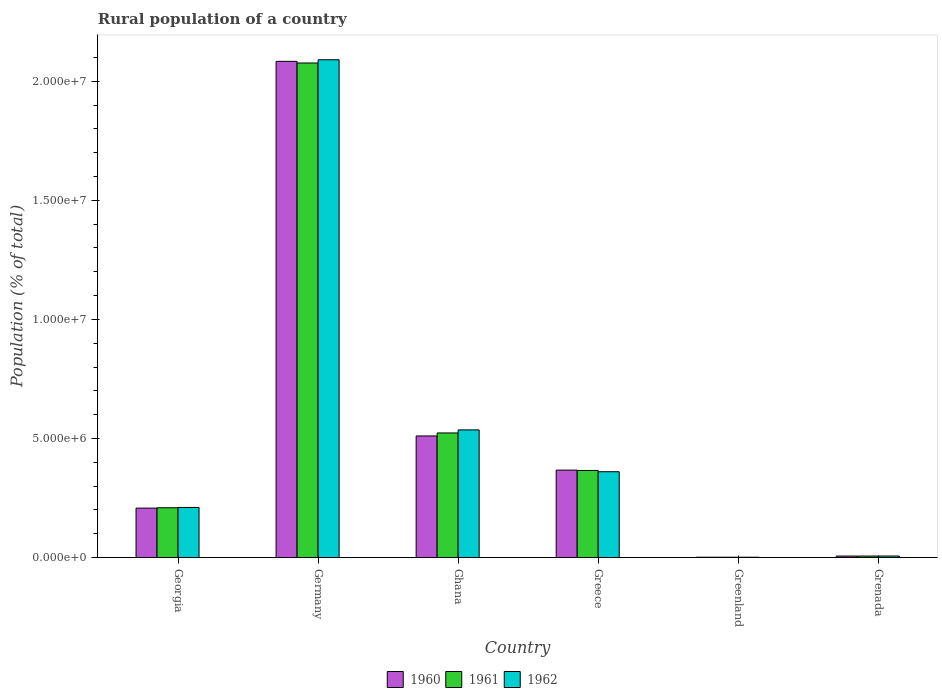How many groups of bars are there?
Provide a short and direct response. 6. What is the label of the 4th group of bars from the left?
Give a very brief answer. Greece. What is the rural population in 1960 in Greenland?
Provide a succinct answer. 1.35e+04. Across all countries, what is the maximum rural population in 1960?
Your answer should be compact. 2.08e+07. Across all countries, what is the minimum rural population in 1960?
Offer a very short reply. 1.35e+04. In which country was the rural population in 1961 maximum?
Provide a succinct answer. Germany. In which country was the rural population in 1962 minimum?
Your answer should be very brief. Greenland. What is the total rural population in 1961 in the graph?
Give a very brief answer. 3.18e+07. What is the difference between the rural population in 1960 in Greece and that in Grenada?
Make the answer very short. 3.61e+06. What is the difference between the rural population in 1960 in Ghana and the rural population in 1962 in Grenada?
Your response must be concise. 5.04e+06. What is the average rural population in 1962 per country?
Your answer should be very brief. 5.34e+06. What is the difference between the rural population of/in 1960 and rural population of/in 1961 in Ghana?
Your answer should be very brief. -1.27e+05. What is the ratio of the rural population in 1962 in Greenland to that in Grenada?
Your answer should be compact. 0.21. What is the difference between the highest and the second highest rural population in 1961?
Provide a succinct answer. 1.58e+06. What is the difference between the highest and the lowest rural population in 1961?
Ensure brevity in your answer.  2.08e+07. In how many countries, is the rural population in 1962 greater than the average rural population in 1962 taken over all countries?
Ensure brevity in your answer.  2. Is the sum of the rural population in 1962 in Georgia and Grenada greater than the maximum rural population in 1960 across all countries?
Provide a short and direct response. No. How many bars are there?
Ensure brevity in your answer.  18. What is the difference between two consecutive major ticks on the Y-axis?
Provide a succinct answer. 5.00e+06. Does the graph contain grids?
Your response must be concise. No. What is the title of the graph?
Your response must be concise. Rural population of a country. Does "1968" appear as one of the legend labels in the graph?
Keep it short and to the point. No. What is the label or title of the Y-axis?
Offer a very short reply. Population (% of total). What is the Population (% of total) in 1960 in Georgia?
Your response must be concise. 2.08e+06. What is the Population (% of total) of 1961 in Georgia?
Offer a very short reply. 2.09e+06. What is the Population (% of total) in 1962 in Georgia?
Your response must be concise. 2.10e+06. What is the Population (% of total) of 1960 in Germany?
Provide a succinct answer. 2.08e+07. What is the Population (% of total) in 1961 in Germany?
Make the answer very short. 2.08e+07. What is the Population (% of total) of 1962 in Germany?
Provide a succinct answer. 2.09e+07. What is the Population (% of total) in 1960 in Ghana?
Give a very brief answer. 5.11e+06. What is the Population (% of total) in 1961 in Ghana?
Provide a succinct answer. 5.23e+06. What is the Population (% of total) in 1962 in Ghana?
Keep it short and to the point. 5.36e+06. What is the Population (% of total) in 1960 in Greece?
Provide a short and direct response. 3.67e+06. What is the Population (% of total) in 1961 in Greece?
Provide a succinct answer. 3.66e+06. What is the Population (% of total) of 1962 in Greece?
Make the answer very short. 3.60e+06. What is the Population (% of total) in 1960 in Greenland?
Make the answer very short. 1.35e+04. What is the Population (% of total) of 1961 in Greenland?
Provide a succinct answer. 1.35e+04. What is the Population (% of total) in 1962 in Greenland?
Offer a very short reply. 1.35e+04. What is the Population (% of total) of 1960 in Grenada?
Provide a short and direct response. 6.26e+04. What is the Population (% of total) in 1961 in Grenada?
Your answer should be compact. 6.34e+04. What is the Population (% of total) of 1962 in Grenada?
Give a very brief answer. 6.40e+04. Across all countries, what is the maximum Population (% of total) in 1960?
Provide a succinct answer. 2.08e+07. Across all countries, what is the maximum Population (% of total) of 1961?
Your response must be concise. 2.08e+07. Across all countries, what is the maximum Population (% of total) of 1962?
Your answer should be very brief. 2.09e+07. Across all countries, what is the minimum Population (% of total) in 1960?
Your answer should be very brief. 1.35e+04. Across all countries, what is the minimum Population (% of total) in 1961?
Your response must be concise. 1.35e+04. Across all countries, what is the minimum Population (% of total) of 1962?
Offer a terse response. 1.35e+04. What is the total Population (% of total) of 1960 in the graph?
Your answer should be compact. 3.18e+07. What is the total Population (% of total) of 1961 in the graph?
Provide a succinct answer. 3.18e+07. What is the total Population (% of total) in 1962 in the graph?
Offer a very short reply. 3.20e+07. What is the difference between the Population (% of total) in 1960 in Georgia and that in Germany?
Your answer should be very brief. -1.88e+07. What is the difference between the Population (% of total) in 1961 in Georgia and that in Germany?
Provide a succinct answer. -1.87e+07. What is the difference between the Population (% of total) of 1962 in Georgia and that in Germany?
Your response must be concise. -1.88e+07. What is the difference between the Population (% of total) in 1960 in Georgia and that in Ghana?
Offer a very short reply. -3.03e+06. What is the difference between the Population (% of total) in 1961 in Georgia and that in Ghana?
Make the answer very short. -3.14e+06. What is the difference between the Population (% of total) of 1962 in Georgia and that in Ghana?
Ensure brevity in your answer.  -3.26e+06. What is the difference between the Population (% of total) in 1960 in Georgia and that in Greece?
Offer a terse response. -1.60e+06. What is the difference between the Population (% of total) in 1961 in Georgia and that in Greece?
Make the answer very short. -1.57e+06. What is the difference between the Population (% of total) in 1962 in Georgia and that in Greece?
Provide a short and direct response. -1.50e+06. What is the difference between the Population (% of total) of 1960 in Georgia and that in Greenland?
Provide a short and direct response. 2.06e+06. What is the difference between the Population (% of total) in 1961 in Georgia and that in Greenland?
Ensure brevity in your answer.  2.08e+06. What is the difference between the Population (% of total) of 1962 in Georgia and that in Greenland?
Offer a terse response. 2.09e+06. What is the difference between the Population (% of total) in 1960 in Georgia and that in Grenada?
Offer a terse response. 2.01e+06. What is the difference between the Population (% of total) of 1961 in Georgia and that in Grenada?
Keep it short and to the point. 2.03e+06. What is the difference between the Population (% of total) in 1962 in Georgia and that in Grenada?
Give a very brief answer. 2.04e+06. What is the difference between the Population (% of total) of 1960 in Germany and that in Ghana?
Your answer should be very brief. 1.57e+07. What is the difference between the Population (% of total) of 1961 in Germany and that in Ghana?
Give a very brief answer. 1.55e+07. What is the difference between the Population (% of total) in 1962 in Germany and that in Ghana?
Your answer should be compact. 1.55e+07. What is the difference between the Population (% of total) of 1960 in Germany and that in Greece?
Keep it short and to the point. 1.72e+07. What is the difference between the Population (% of total) of 1961 in Germany and that in Greece?
Your answer should be compact. 1.71e+07. What is the difference between the Population (% of total) of 1962 in Germany and that in Greece?
Provide a short and direct response. 1.73e+07. What is the difference between the Population (% of total) in 1960 in Germany and that in Greenland?
Your answer should be very brief. 2.08e+07. What is the difference between the Population (% of total) in 1961 in Germany and that in Greenland?
Your response must be concise. 2.08e+07. What is the difference between the Population (% of total) in 1962 in Germany and that in Greenland?
Make the answer very short. 2.09e+07. What is the difference between the Population (% of total) of 1960 in Germany and that in Grenada?
Your response must be concise. 2.08e+07. What is the difference between the Population (% of total) of 1961 in Germany and that in Grenada?
Provide a succinct answer. 2.07e+07. What is the difference between the Population (% of total) in 1962 in Germany and that in Grenada?
Provide a succinct answer. 2.08e+07. What is the difference between the Population (% of total) in 1960 in Ghana and that in Greece?
Offer a terse response. 1.43e+06. What is the difference between the Population (% of total) of 1961 in Ghana and that in Greece?
Give a very brief answer. 1.58e+06. What is the difference between the Population (% of total) of 1962 in Ghana and that in Greece?
Your answer should be compact. 1.76e+06. What is the difference between the Population (% of total) in 1960 in Ghana and that in Greenland?
Your answer should be very brief. 5.09e+06. What is the difference between the Population (% of total) of 1961 in Ghana and that in Greenland?
Your answer should be compact. 5.22e+06. What is the difference between the Population (% of total) of 1962 in Ghana and that in Greenland?
Provide a short and direct response. 5.35e+06. What is the difference between the Population (% of total) in 1960 in Ghana and that in Grenada?
Give a very brief answer. 5.04e+06. What is the difference between the Population (% of total) of 1961 in Ghana and that in Grenada?
Your answer should be compact. 5.17e+06. What is the difference between the Population (% of total) in 1962 in Ghana and that in Grenada?
Provide a short and direct response. 5.30e+06. What is the difference between the Population (% of total) in 1960 in Greece and that in Greenland?
Offer a terse response. 3.66e+06. What is the difference between the Population (% of total) in 1961 in Greece and that in Greenland?
Provide a short and direct response. 3.64e+06. What is the difference between the Population (% of total) in 1962 in Greece and that in Greenland?
Give a very brief answer. 3.59e+06. What is the difference between the Population (% of total) in 1960 in Greece and that in Grenada?
Keep it short and to the point. 3.61e+06. What is the difference between the Population (% of total) of 1961 in Greece and that in Grenada?
Provide a succinct answer. 3.59e+06. What is the difference between the Population (% of total) of 1962 in Greece and that in Grenada?
Give a very brief answer. 3.54e+06. What is the difference between the Population (% of total) of 1960 in Greenland and that in Grenada?
Your response must be concise. -4.91e+04. What is the difference between the Population (% of total) in 1961 in Greenland and that in Grenada?
Provide a short and direct response. -4.99e+04. What is the difference between the Population (% of total) of 1962 in Greenland and that in Grenada?
Give a very brief answer. -5.05e+04. What is the difference between the Population (% of total) in 1960 in Georgia and the Population (% of total) in 1961 in Germany?
Provide a short and direct response. -1.87e+07. What is the difference between the Population (% of total) in 1960 in Georgia and the Population (% of total) in 1962 in Germany?
Make the answer very short. -1.88e+07. What is the difference between the Population (% of total) of 1961 in Georgia and the Population (% of total) of 1962 in Germany?
Keep it short and to the point. -1.88e+07. What is the difference between the Population (% of total) in 1960 in Georgia and the Population (% of total) in 1961 in Ghana?
Provide a succinct answer. -3.16e+06. What is the difference between the Population (% of total) in 1960 in Georgia and the Population (% of total) in 1962 in Ghana?
Give a very brief answer. -3.28e+06. What is the difference between the Population (% of total) of 1961 in Georgia and the Population (% of total) of 1962 in Ghana?
Ensure brevity in your answer.  -3.27e+06. What is the difference between the Population (% of total) of 1960 in Georgia and the Population (% of total) of 1961 in Greece?
Give a very brief answer. -1.58e+06. What is the difference between the Population (% of total) in 1960 in Georgia and the Population (% of total) in 1962 in Greece?
Your response must be concise. -1.53e+06. What is the difference between the Population (% of total) of 1961 in Georgia and the Population (% of total) of 1962 in Greece?
Keep it short and to the point. -1.51e+06. What is the difference between the Population (% of total) in 1960 in Georgia and the Population (% of total) in 1961 in Greenland?
Ensure brevity in your answer.  2.06e+06. What is the difference between the Population (% of total) of 1960 in Georgia and the Population (% of total) of 1962 in Greenland?
Offer a terse response. 2.06e+06. What is the difference between the Population (% of total) of 1961 in Georgia and the Population (% of total) of 1962 in Greenland?
Offer a terse response. 2.08e+06. What is the difference between the Population (% of total) in 1960 in Georgia and the Population (% of total) in 1961 in Grenada?
Your answer should be compact. 2.01e+06. What is the difference between the Population (% of total) in 1960 in Georgia and the Population (% of total) in 1962 in Grenada?
Give a very brief answer. 2.01e+06. What is the difference between the Population (% of total) of 1961 in Georgia and the Population (% of total) of 1962 in Grenada?
Offer a very short reply. 2.03e+06. What is the difference between the Population (% of total) of 1960 in Germany and the Population (% of total) of 1961 in Ghana?
Provide a succinct answer. 1.56e+07. What is the difference between the Population (% of total) in 1960 in Germany and the Population (% of total) in 1962 in Ghana?
Make the answer very short. 1.55e+07. What is the difference between the Population (% of total) of 1961 in Germany and the Population (% of total) of 1962 in Ghana?
Ensure brevity in your answer.  1.54e+07. What is the difference between the Population (% of total) in 1960 in Germany and the Population (% of total) in 1961 in Greece?
Keep it short and to the point. 1.72e+07. What is the difference between the Population (% of total) in 1960 in Germany and the Population (% of total) in 1962 in Greece?
Keep it short and to the point. 1.72e+07. What is the difference between the Population (% of total) in 1961 in Germany and the Population (% of total) in 1962 in Greece?
Your response must be concise. 1.72e+07. What is the difference between the Population (% of total) of 1960 in Germany and the Population (% of total) of 1961 in Greenland?
Offer a terse response. 2.08e+07. What is the difference between the Population (% of total) in 1960 in Germany and the Population (% of total) in 1962 in Greenland?
Offer a terse response. 2.08e+07. What is the difference between the Population (% of total) in 1961 in Germany and the Population (% of total) in 1962 in Greenland?
Provide a short and direct response. 2.08e+07. What is the difference between the Population (% of total) of 1960 in Germany and the Population (% of total) of 1961 in Grenada?
Your answer should be very brief. 2.08e+07. What is the difference between the Population (% of total) of 1960 in Germany and the Population (% of total) of 1962 in Grenada?
Make the answer very short. 2.08e+07. What is the difference between the Population (% of total) in 1961 in Germany and the Population (% of total) in 1962 in Grenada?
Ensure brevity in your answer.  2.07e+07. What is the difference between the Population (% of total) in 1960 in Ghana and the Population (% of total) in 1961 in Greece?
Keep it short and to the point. 1.45e+06. What is the difference between the Population (% of total) of 1960 in Ghana and the Population (% of total) of 1962 in Greece?
Keep it short and to the point. 1.50e+06. What is the difference between the Population (% of total) of 1961 in Ghana and the Population (% of total) of 1962 in Greece?
Offer a very short reply. 1.63e+06. What is the difference between the Population (% of total) in 1960 in Ghana and the Population (% of total) in 1961 in Greenland?
Offer a very short reply. 5.09e+06. What is the difference between the Population (% of total) of 1960 in Ghana and the Population (% of total) of 1962 in Greenland?
Keep it short and to the point. 5.09e+06. What is the difference between the Population (% of total) of 1961 in Ghana and the Population (% of total) of 1962 in Greenland?
Your answer should be very brief. 5.22e+06. What is the difference between the Population (% of total) of 1960 in Ghana and the Population (% of total) of 1961 in Grenada?
Your answer should be compact. 5.04e+06. What is the difference between the Population (% of total) of 1960 in Ghana and the Population (% of total) of 1962 in Grenada?
Your answer should be compact. 5.04e+06. What is the difference between the Population (% of total) of 1961 in Ghana and the Population (% of total) of 1962 in Grenada?
Keep it short and to the point. 5.17e+06. What is the difference between the Population (% of total) in 1960 in Greece and the Population (% of total) in 1961 in Greenland?
Your answer should be very brief. 3.66e+06. What is the difference between the Population (% of total) in 1960 in Greece and the Population (% of total) in 1962 in Greenland?
Offer a terse response. 3.66e+06. What is the difference between the Population (% of total) in 1961 in Greece and the Population (% of total) in 1962 in Greenland?
Ensure brevity in your answer.  3.64e+06. What is the difference between the Population (% of total) of 1960 in Greece and the Population (% of total) of 1961 in Grenada?
Provide a short and direct response. 3.61e+06. What is the difference between the Population (% of total) of 1960 in Greece and the Population (% of total) of 1962 in Grenada?
Provide a succinct answer. 3.61e+06. What is the difference between the Population (% of total) of 1961 in Greece and the Population (% of total) of 1962 in Grenada?
Offer a terse response. 3.59e+06. What is the difference between the Population (% of total) in 1960 in Greenland and the Population (% of total) in 1961 in Grenada?
Provide a short and direct response. -4.99e+04. What is the difference between the Population (% of total) in 1960 in Greenland and the Population (% of total) in 1962 in Grenada?
Ensure brevity in your answer.  -5.06e+04. What is the difference between the Population (% of total) of 1961 in Greenland and the Population (% of total) of 1962 in Grenada?
Keep it short and to the point. -5.05e+04. What is the average Population (% of total) in 1960 per country?
Ensure brevity in your answer.  5.29e+06. What is the average Population (% of total) in 1961 per country?
Your response must be concise. 5.30e+06. What is the average Population (% of total) of 1962 per country?
Give a very brief answer. 5.34e+06. What is the difference between the Population (% of total) of 1960 and Population (% of total) of 1961 in Georgia?
Keep it short and to the point. -1.49e+04. What is the difference between the Population (% of total) of 1960 and Population (% of total) of 1962 in Georgia?
Ensure brevity in your answer.  -2.84e+04. What is the difference between the Population (% of total) of 1961 and Population (% of total) of 1962 in Georgia?
Offer a very short reply. -1.35e+04. What is the difference between the Population (% of total) of 1960 and Population (% of total) of 1961 in Germany?
Provide a short and direct response. 6.86e+04. What is the difference between the Population (% of total) in 1960 and Population (% of total) in 1962 in Germany?
Your answer should be very brief. -6.67e+04. What is the difference between the Population (% of total) of 1961 and Population (% of total) of 1962 in Germany?
Offer a very short reply. -1.35e+05. What is the difference between the Population (% of total) in 1960 and Population (% of total) in 1961 in Ghana?
Provide a short and direct response. -1.27e+05. What is the difference between the Population (% of total) in 1960 and Population (% of total) in 1962 in Ghana?
Ensure brevity in your answer.  -2.55e+05. What is the difference between the Population (% of total) of 1961 and Population (% of total) of 1962 in Ghana?
Ensure brevity in your answer.  -1.27e+05. What is the difference between the Population (% of total) of 1960 and Population (% of total) of 1961 in Greece?
Provide a short and direct response. 1.42e+04. What is the difference between the Population (% of total) of 1960 and Population (% of total) of 1962 in Greece?
Offer a very short reply. 6.73e+04. What is the difference between the Population (% of total) of 1961 and Population (% of total) of 1962 in Greece?
Provide a succinct answer. 5.31e+04. What is the difference between the Population (% of total) of 1960 and Population (% of total) of 1961 in Greenland?
Provide a succinct answer. -69. What is the difference between the Population (% of total) in 1960 and Population (% of total) in 1962 in Greenland?
Your response must be concise. -32. What is the difference between the Population (% of total) in 1961 and Population (% of total) in 1962 in Greenland?
Ensure brevity in your answer.  37. What is the difference between the Population (% of total) of 1960 and Population (% of total) of 1961 in Grenada?
Provide a succinct answer. -804. What is the difference between the Population (% of total) in 1960 and Population (% of total) in 1962 in Grenada?
Give a very brief answer. -1439. What is the difference between the Population (% of total) of 1961 and Population (% of total) of 1962 in Grenada?
Your response must be concise. -635. What is the ratio of the Population (% of total) in 1960 in Georgia to that in Germany?
Provide a short and direct response. 0.1. What is the ratio of the Population (% of total) in 1961 in Georgia to that in Germany?
Offer a terse response. 0.1. What is the ratio of the Population (% of total) in 1962 in Georgia to that in Germany?
Your answer should be very brief. 0.1. What is the ratio of the Population (% of total) in 1960 in Georgia to that in Ghana?
Ensure brevity in your answer.  0.41. What is the ratio of the Population (% of total) of 1961 in Georgia to that in Ghana?
Make the answer very short. 0.4. What is the ratio of the Population (% of total) of 1962 in Georgia to that in Ghana?
Give a very brief answer. 0.39. What is the ratio of the Population (% of total) in 1960 in Georgia to that in Greece?
Ensure brevity in your answer.  0.57. What is the ratio of the Population (% of total) of 1961 in Georgia to that in Greece?
Offer a terse response. 0.57. What is the ratio of the Population (% of total) of 1962 in Georgia to that in Greece?
Offer a terse response. 0.58. What is the ratio of the Population (% of total) in 1960 in Georgia to that in Greenland?
Your answer should be very brief. 154.01. What is the ratio of the Population (% of total) of 1961 in Georgia to that in Greenland?
Give a very brief answer. 154.33. What is the ratio of the Population (% of total) of 1962 in Georgia to that in Greenland?
Provide a succinct answer. 155.75. What is the ratio of the Population (% of total) in 1960 in Georgia to that in Grenada?
Provide a succinct answer. 33.15. What is the ratio of the Population (% of total) in 1961 in Georgia to that in Grenada?
Offer a very short reply. 32.97. What is the ratio of the Population (% of total) in 1962 in Georgia to that in Grenada?
Provide a short and direct response. 32.85. What is the ratio of the Population (% of total) of 1960 in Germany to that in Ghana?
Your response must be concise. 4.08. What is the ratio of the Population (% of total) of 1961 in Germany to that in Ghana?
Provide a short and direct response. 3.97. What is the ratio of the Population (% of total) in 1962 in Germany to that in Ghana?
Offer a terse response. 3.9. What is the ratio of the Population (% of total) of 1960 in Germany to that in Greece?
Offer a very short reply. 5.68. What is the ratio of the Population (% of total) in 1961 in Germany to that in Greece?
Ensure brevity in your answer.  5.68. What is the ratio of the Population (% of total) in 1960 in Germany to that in Greenland?
Make the answer very short. 1546.21. What is the ratio of the Population (% of total) in 1961 in Germany to that in Greenland?
Offer a very short reply. 1533.26. What is the ratio of the Population (% of total) of 1962 in Germany to that in Greenland?
Provide a short and direct response. 1547.48. What is the ratio of the Population (% of total) in 1960 in Germany to that in Grenada?
Make the answer very short. 332.83. What is the ratio of the Population (% of total) in 1961 in Germany to that in Grenada?
Offer a very short reply. 327.53. What is the ratio of the Population (% of total) of 1962 in Germany to that in Grenada?
Provide a short and direct response. 326.4. What is the ratio of the Population (% of total) of 1960 in Ghana to that in Greece?
Keep it short and to the point. 1.39. What is the ratio of the Population (% of total) in 1961 in Ghana to that in Greece?
Provide a succinct answer. 1.43. What is the ratio of the Population (% of total) in 1962 in Ghana to that in Greece?
Your answer should be very brief. 1.49. What is the ratio of the Population (% of total) of 1960 in Ghana to that in Greenland?
Make the answer very short. 378.86. What is the ratio of the Population (% of total) of 1961 in Ghana to that in Greenland?
Your answer should be very brief. 386.31. What is the ratio of the Population (% of total) in 1962 in Ghana to that in Greenland?
Ensure brevity in your answer.  396.8. What is the ratio of the Population (% of total) of 1960 in Ghana to that in Grenada?
Your answer should be very brief. 81.55. What is the ratio of the Population (% of total) in 1961 in Ghana to that in Grenada?
Your answer should be compact. 82.52. What is the ratio of the Population (% of total) in 1962 in Ghana to that in Grenada?
Provide a succinct answer. 83.69. What is the ratio of the Population (% of total) in 1960 in Greece to that in Greenland?
Offer a terse response. 272.43. What is the ratio of the Population (% of total) of 1961 in Greece to that in Greenland?
Your answer should be compact. 270. What is the ratio of the Population (% of total) in 1962 in Greece to that in Greenland?
Offer a terse response. 266.81. What is the ratio of the Population (% of total) in 1960 in Greece to that in Grenada?
Give a very brief answer. 58.64. What is the ratio of the Population (% of total) in 1961 in Greece to that in Grenada?
Your answer should be very brief. 57.68. What is the ratio of the Population (% of total) of 1962 in Greece to that in Grenada?
Your answer should be very brief. 56.27. What is the ratio of the Population (% of total) in 1960 in Greenland to that in Grenada?
Provide a short and direct response. 0.22. What is the ratio of the Population (% of total) of 1961 in Greenland to that in Grenada?
Offer a terse response. 0.21. What is the ratio of the Population (% of total) in 1962 in Greenland to that in Grenada?
Your answer should be compact. 0.21. What is the difference between the highest and the second highest Population (% of total) of 1960?
Provide a short and direct response. 1.57e+07. What is the difference between the highest and the second highest Population (% of total) in 1961?
Give a very brief answer. 1.55e+07. What is the difference between the highest and the second highest Population (% of total) in 1962?
Your answer should be compact. 1.55e+07. What is the difference between the highest and the lowest Population (% of total) of 1960?
Provide a succinct answer. 2.08e+07. What is the difference between the highest and the lowest Population (% of total) of 1961?
Provide a short and direct response. 2.08e+07. What is the difference between the highest and the lowest Population (% of total) of 1962?
Offer a terse response. 2.09e+07. 